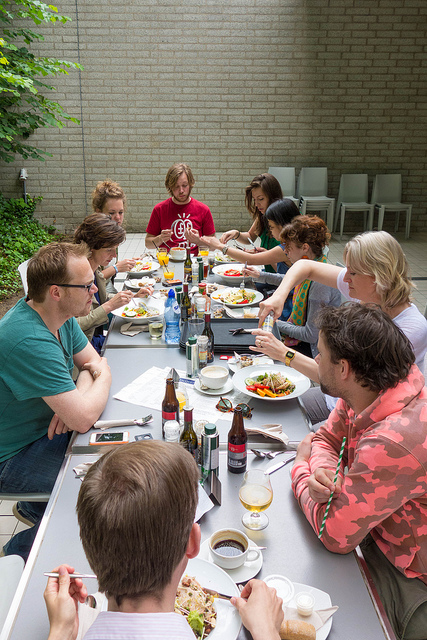Identify the text contained in this image. L 